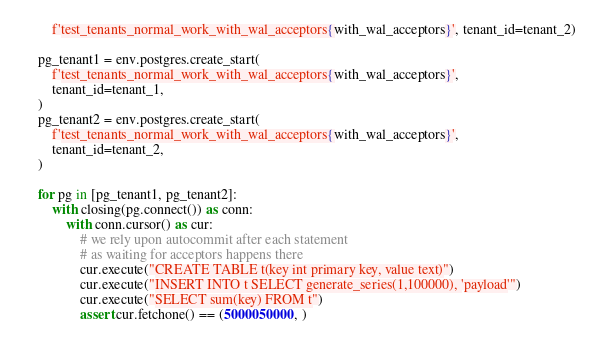<code> <loc_0><loc_0><loc_500><loc_500><_Python_>        f'test_tenants_normal_work_with_wal_acceptors{with_wal_acceptors}', tenant_id=tenant_2)

    pg_tenant1 = env.postgres.create_start(
        f'test_tenants_normal_work_with_wal_acceptors{with_wal_acceptors}',
        tenant_id=tenant_1,
    )
    pg_tenant2 = env.postgres.create_start(
        f'test_tenants_normal_work_with_wal_acceptors{with_wal_acceptors}',
        tenant_id=tenant_2,
    )

    for pg in [pg_tenant1, pg_tenant2]:
        with closing(pg.connect()) as conn:
            with conn.cursor() as cur:
                # we rely upon autocommit after each statement
                # as waiting for acceptors happens there
                cur.execute("CREATE TABLE t(key int primary key, value text)")
                cur.execute("INSERT INTO t SELECT generate_series(1,100000), 'payload'")
                cur.execute("SELECT sum(key) FROM t")
                assert cur.fetchone() == (5000050000, )
</code> 